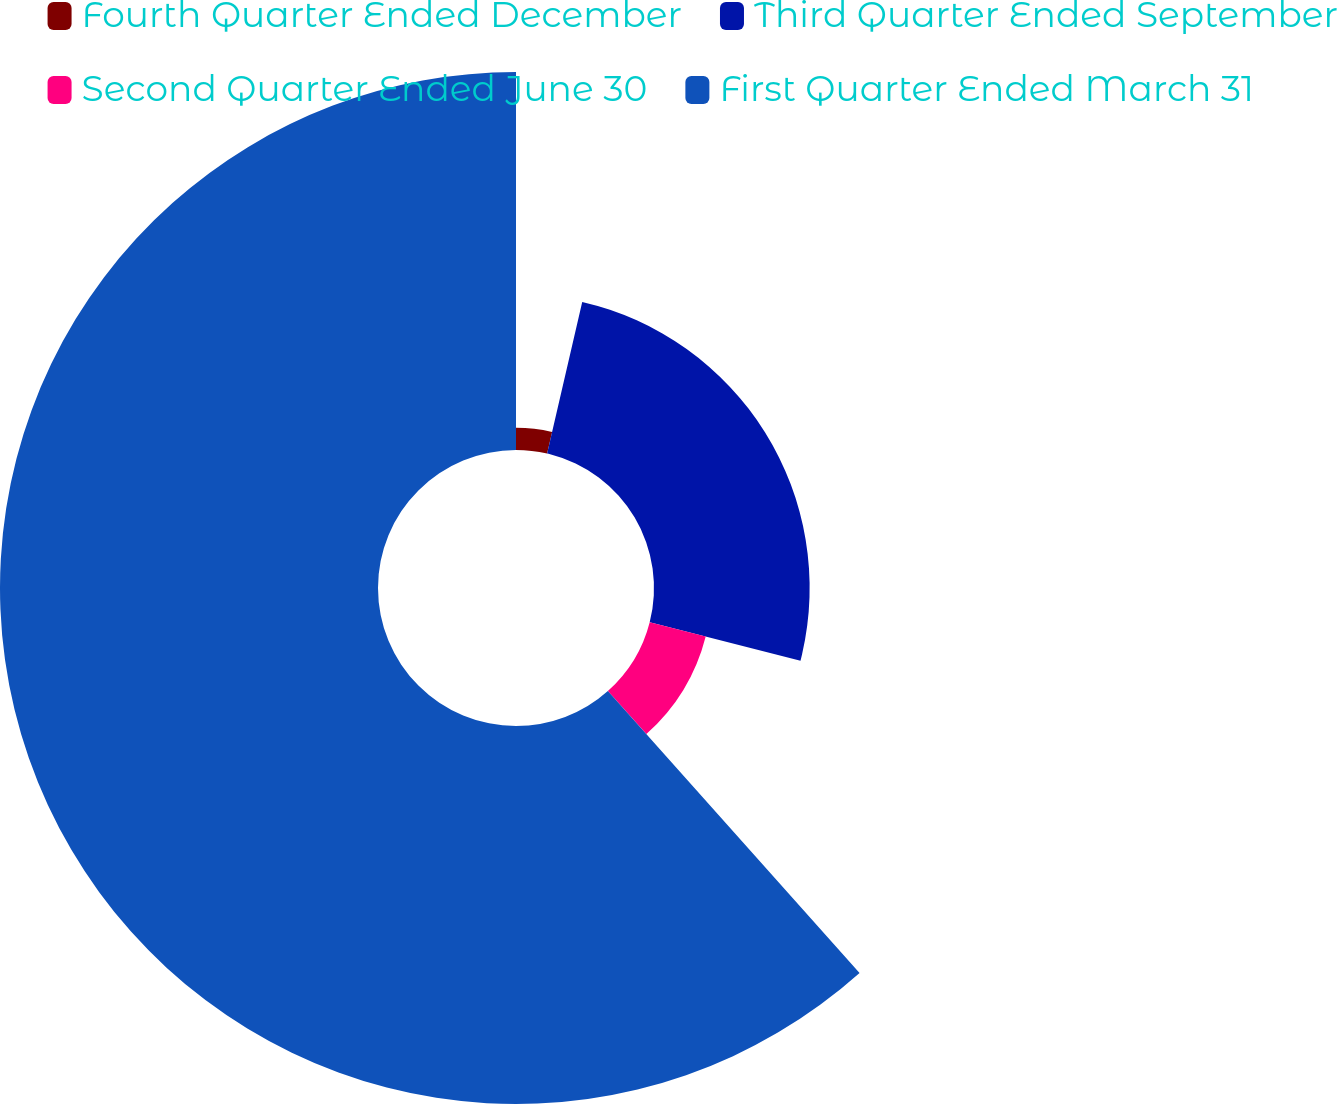Convert chart. <chart><loc_0><loc_0><loc_500><loc_500><pie_chart><fcel>Fourth Quarter Ended December<fcel>Third Quarter Ended September<fcel>Second Quarter Ended June 30<fcel>First Quarter Ended March 31<nl><fcel>3.62%<fcel>25.36%<fcel>9.42%<fcel>61.59%<nl></chart> 